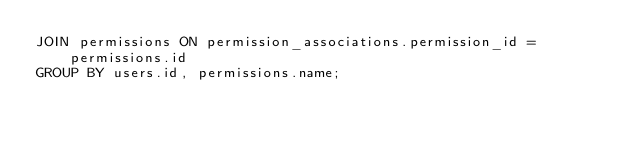<code> <loc_0><loc_0><loc_500><loc_500><_SQL_>JOIN permissions ON permission_associations.permission_id = permissions.id
GROUP BY users.id, permissions.name;
</code> 